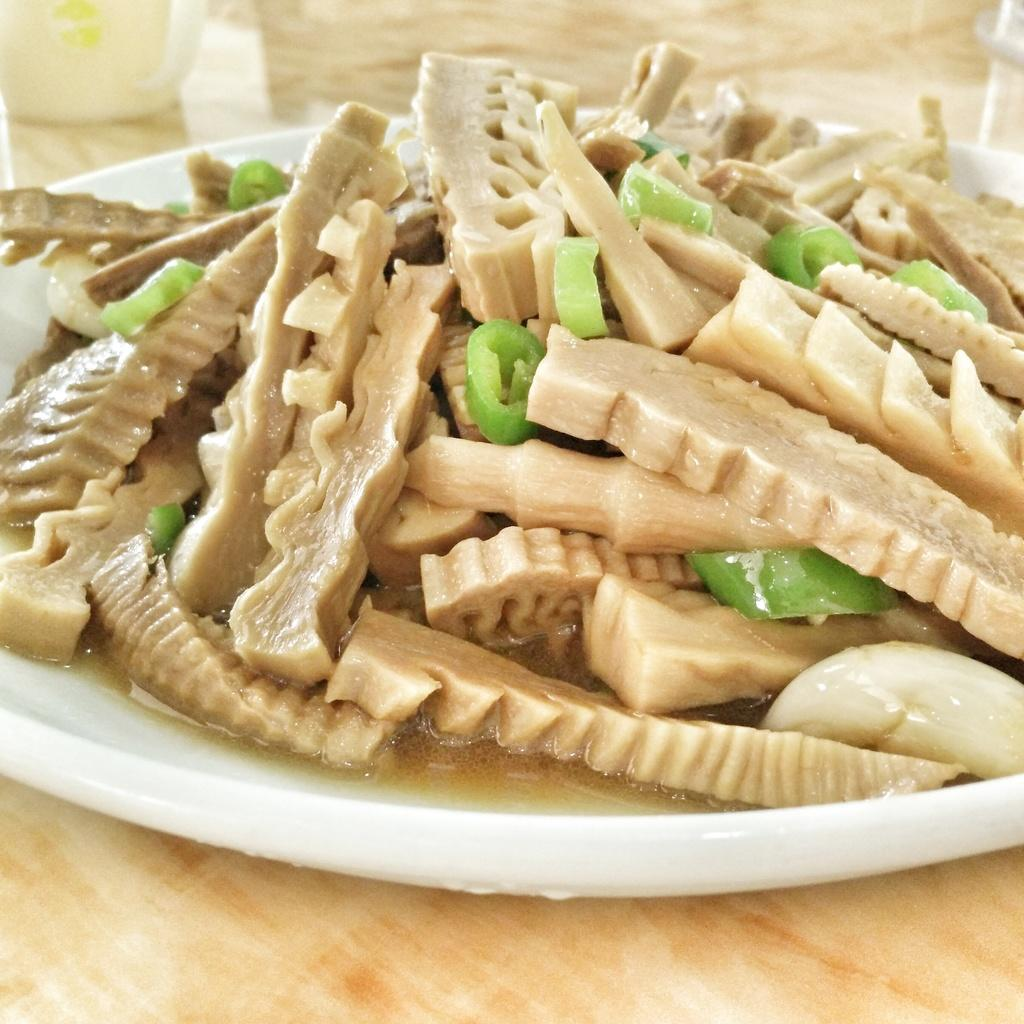What is on the plate that is visible in the image? There is a plate with food in the image. What type of container is present in the image? There is a cup in the image. What material is the platform made of in the image? The wooden platform is present in the image. What type of stone can be seen kicking the ball in the image? There is no stone or ball present in the image; it features a plate with food, a cup, and a wooden platform. 